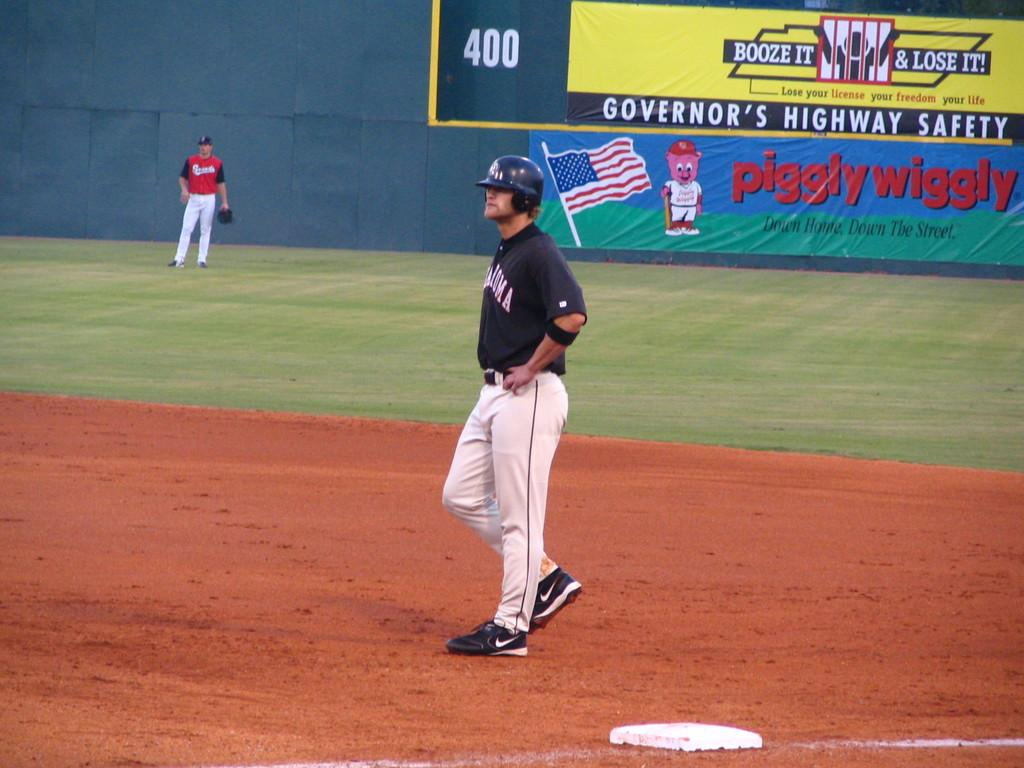<image>
Describe the image concisely. A baseball player is on a field in front of a piggle wiggly sign. 